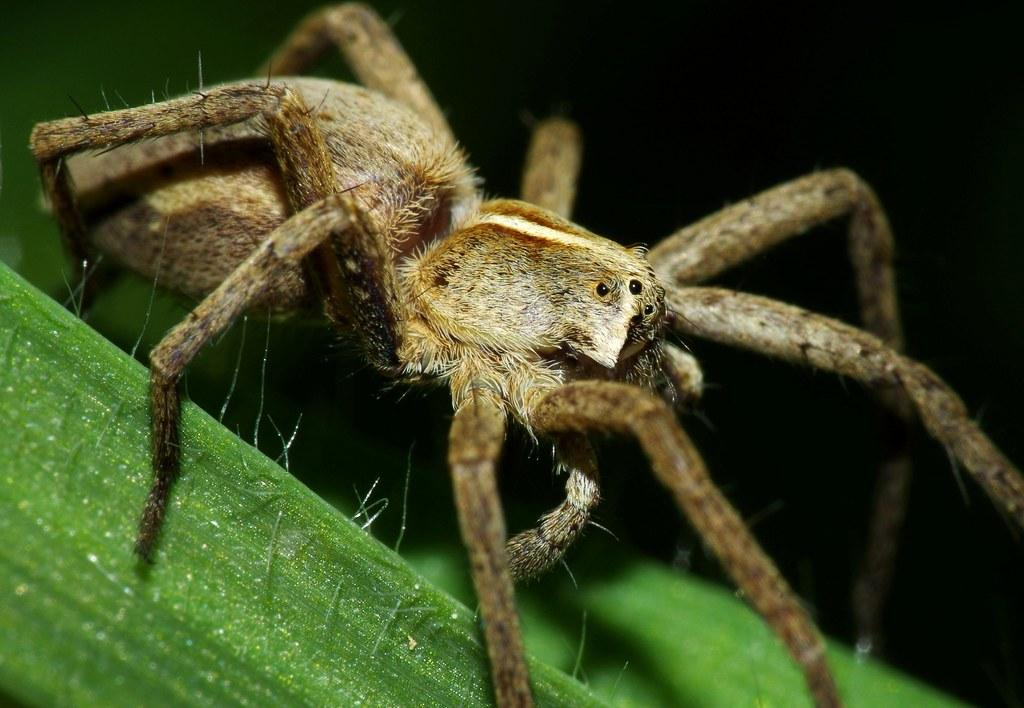What is the main subject of the picture? The main subject of the picture is a spider. Where is the spider located in the image? The spider is on a green object. How many clocks are visible in the image? There are no clocks present in the image; it features a spider on a green object. What type of creature is shown interacting with the crib in the image? There is no crib present in the image, and therefore no such interaction can be observed. 